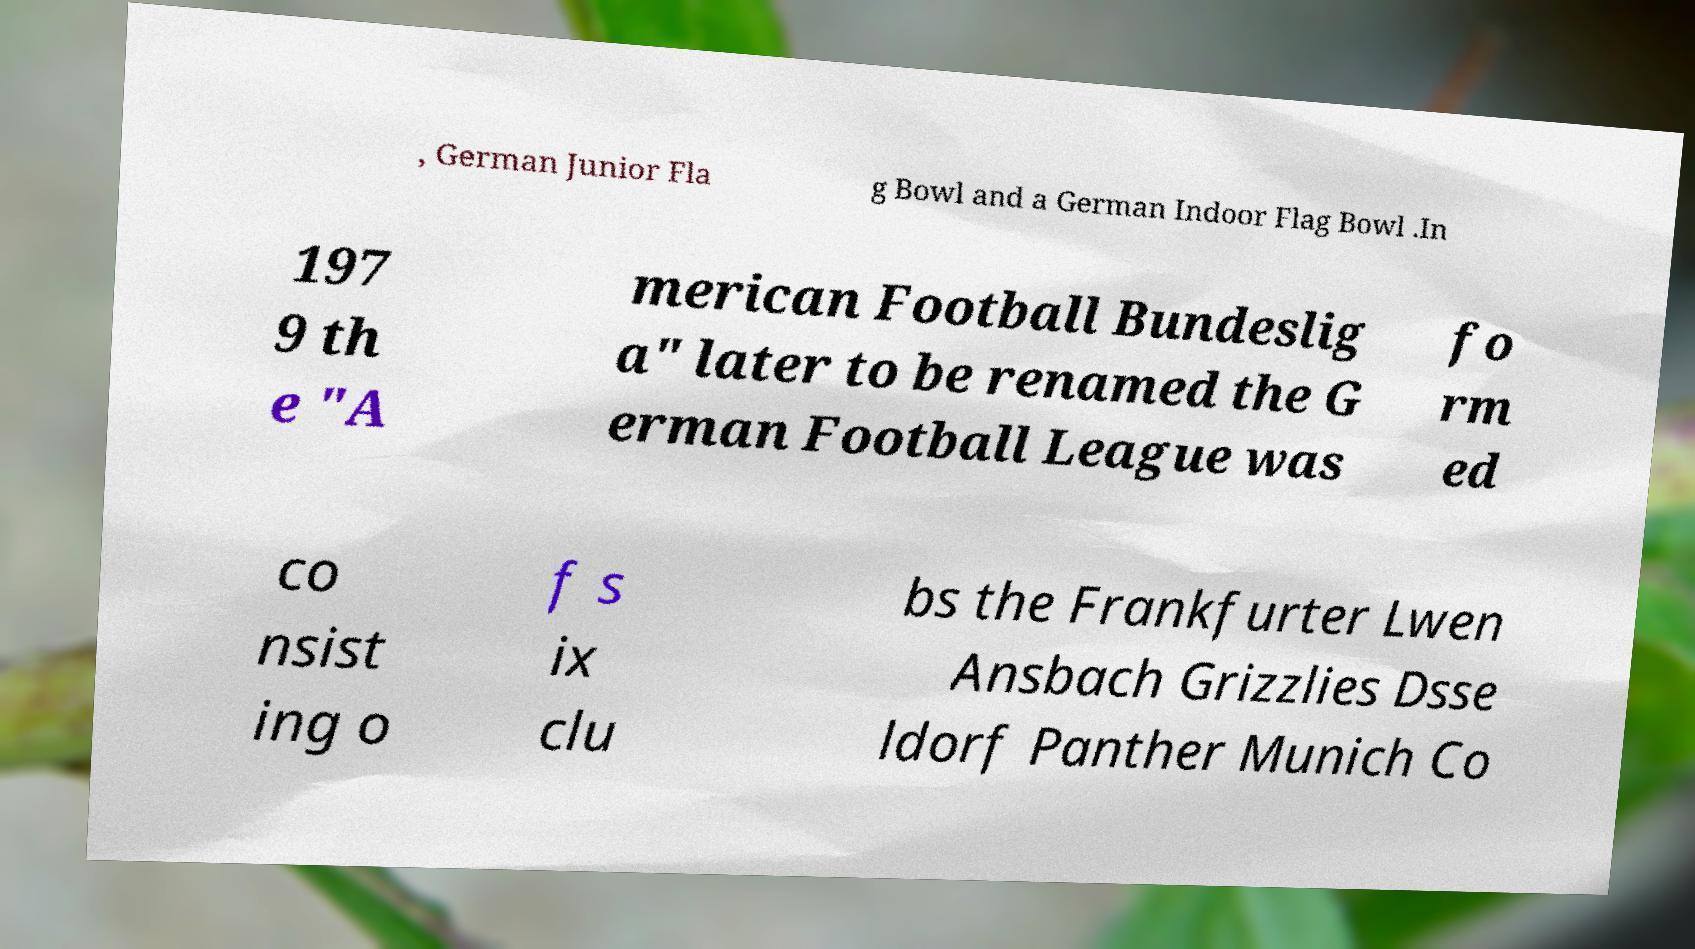What messages or text are displayed in this image? I need them in a readable, typed format. , German Junior Fla g Bowl and a German Indoor Flag Bowl .In 197 9 th e "A merican Football Bundeslig a" later to be renamed the G erman Football League was fo rm ed co nsist ing o f s ix clu bs the Frankfurter Lwen Ansbach Grizzlies Dsse ldorf Panther Munich Co 